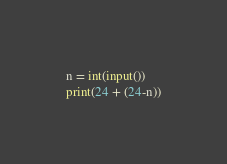<code> <loc_0><loc_0><loc_500><loc_500><_Python_>n = int(input())
print(24 + (24-n))</code> 